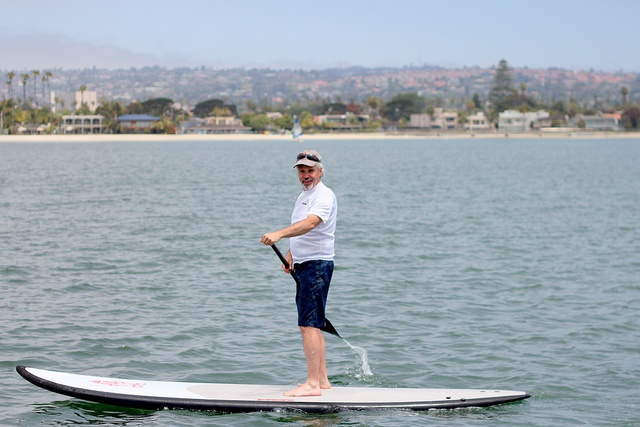Describe the objects in this image and their specific colors. I can see surfboard in lavender, white, black, gray, and darkgray tones and people in lavender, black, salmon, and darkgray tones in this image. 